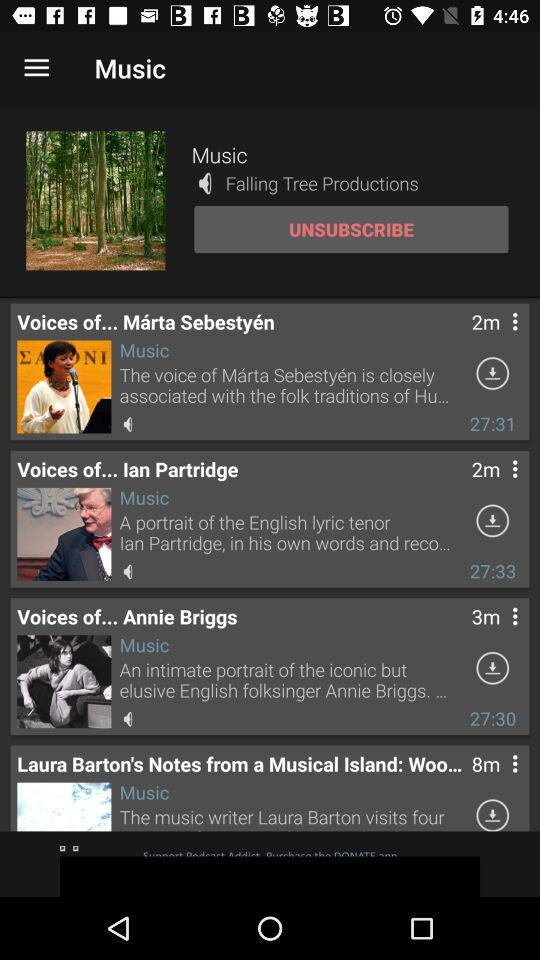What is the music channel's name? The music channel's name is "Falling Tree Productions". 